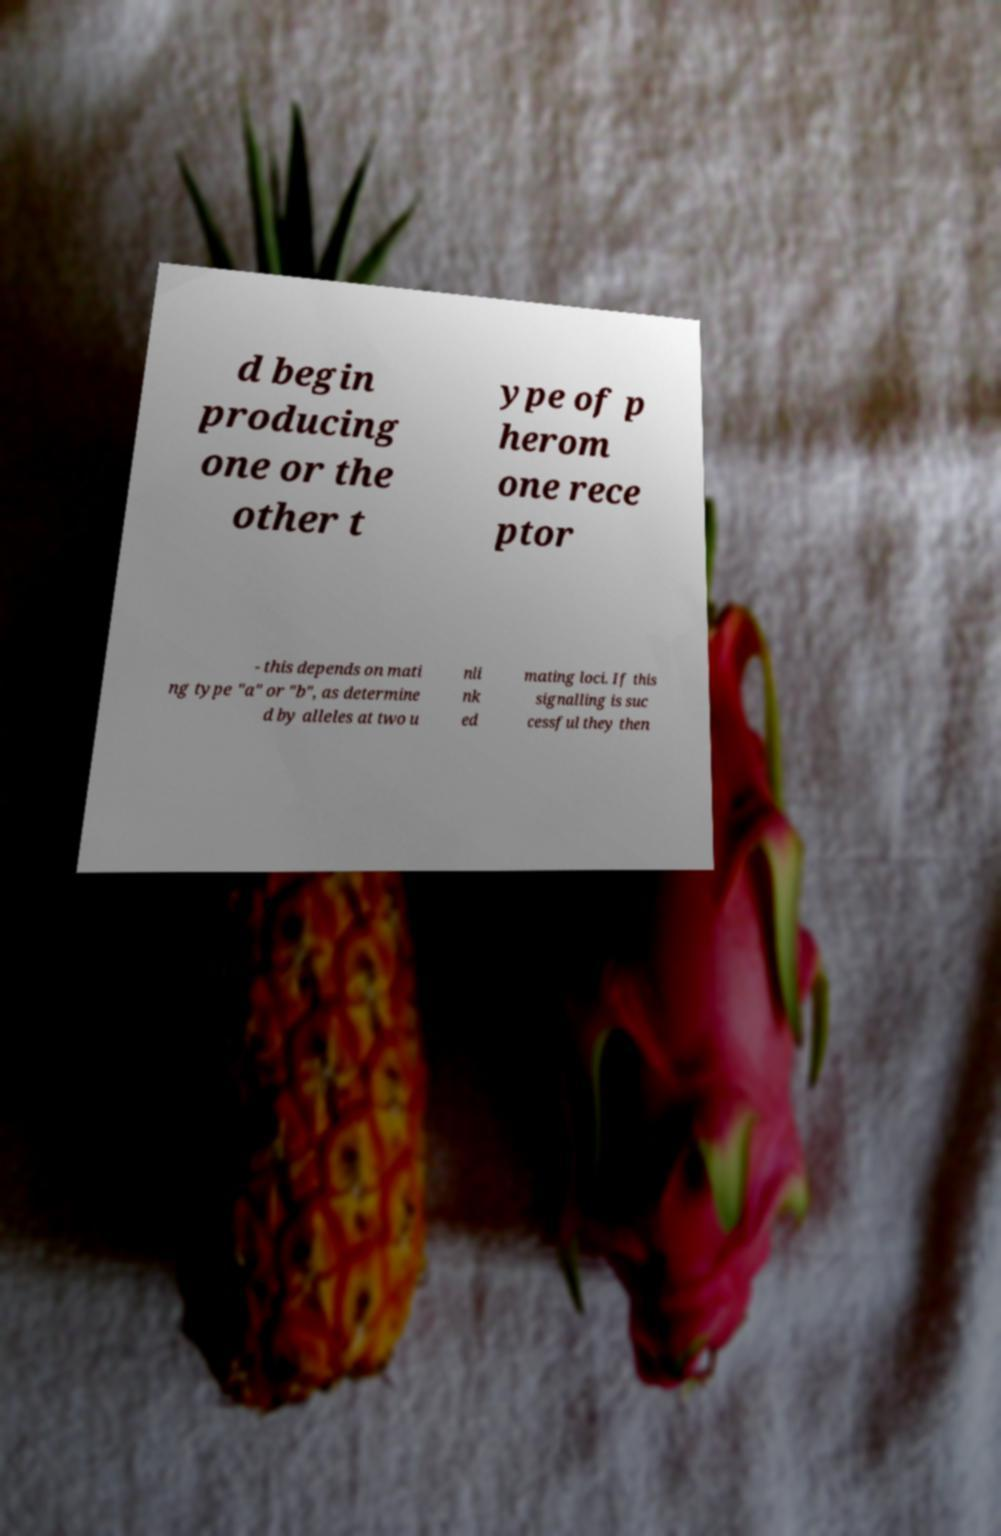There's text embedded in this image that I need extracted. Can you transcribe it verbatim? d begin producing one or the other t ype of p herom one rece ptor - this depends on mati ng type "a" or "b", as determine d by alleles at two u nli nk ed mating loci. If this signalling is suc cessful they then 